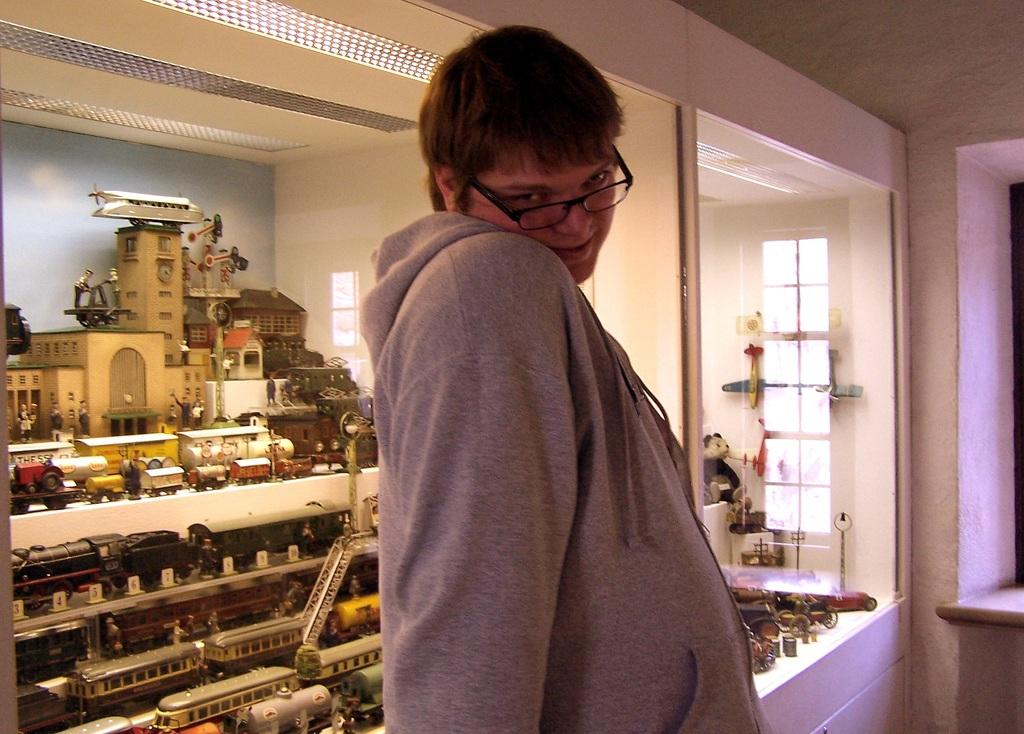Who is present in the image? There is a person in the image. What can be observed about the person's appearance? The person is wearing spectacles. What can be seen in the background of the image? There are toys and a wall in the background of the image. How many fingers does the person have in the image? The number of fingers the person has cannot be determined from the image, as hands are not visible. 